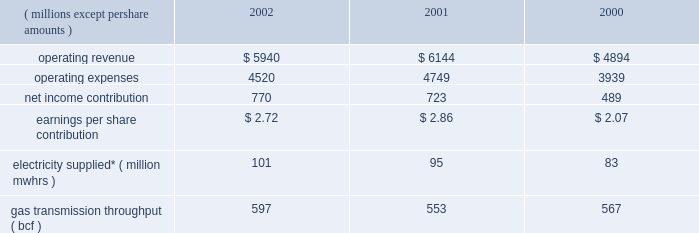Other taxes decreased in 2001 because its utility operations in virginia became subject to state income taxes in lieu of gross receipts taxes effective january 2001 .
In addition , dominion recognized higher effective rates for foreign earnings and higher pretax income in relation to non-conventional fuel tax credits realized .
Dominion energy 2002 2001 2000 ( millions , except per share amounts ) .
* amounts presented are for electricity supplied by utility and merchant generation operations .
Operating results 2014 2002 dominion energy contributed $ 2.72 per diluted share on net income of $ 770 million for 2002 , a net income increase of $ 47 million and an earnings per share decrease of $ 0.14 over 2001 .
Net income for 2002 reflected lower operating revenue ( $ 204 million ) , operating expenses ( $ 229 million ) and other income ( $ 27 million ) .
Interest expense and income taxes , which are discussed on a consolidated basis , decreased $ 50 million over 2001 .
The earnings per share decrease reflected share dilution .
Regulated electric sales revenue increased $ 179 million .
Favorable weather conditions , reflecting increased cooling and heating degree-days , as well as customer growth , are estimated to have contributed $ 133 million and $ 41 million , respectively .
Fuel rate recoveries increased approximately $ 65 million for 2002 .
These recoveries are generally offset by increases in elec- tric fuel expense and do not materially affect income .
Partially offsetting these increases was a net decrease of $ 60 million due to other factors not separately measurable , such as the impact of economic conditions on customer usage , as well as variations in seasonal rate premiums and discounts .
Nonregulated electric sales revenue increased $ 9 million .
Sales revenue from dominion 2019s merchant generation fleet decreased $ 21 million , reflecting a $ 201 million decline due to lower prices partially offset by sales from assets acquired and constructed in 2002 and the inclusion of millstone operations for all of 2002 .
Revenue from the wholesale marketing of utility generation decreased $ 74 million .
Due to the higher demand of utility service territory customers during 2002 , less production from utility plant generation was available for profitable sale in the wholesale market .
Revenue from retail energy sales increased $ 71 million , reflecting primarily customer growth over the prior year .
Net revenue from dominion 2019s electric trading activities increased $ 33 million , reflecting the effect of favorable price changes on unsettled contracts and higher trading margins .
Nonregulated gas sales revenue decreased $ 351 million .
The decrease included a $ 239 million decrease in sales by dominion 2019s field services and retail energy marketing opera- tions , reflecting to a large extent declining prices .
Revenue associated with gas trading operations , net of related cost of sales , decreased $ 112 million .
The decrease included $ 70 mil- lion of realized and unrealized losses on the economic hedges of natural gas production by the dominion exploration & pro- duction segment .
As described below under selected information 2014 energy trading activities , sales of natural gas by the dominion exploration & production segment at market prices offset these financial losses , resulting in a range of prices contemplated by dominion 2019s overall risk management strategy .
The remaining $ 42 million decrease was due to unfavorable price changes on unsettled contracts and lower overall trading margins .
Those losses were partially offset by contributions from higher trading volumes in gas and oil markets .
Gas transportation and storage revenue decreased $ 44 million , primarily reflecting lower rates .
Electric fuel and energy purchases expense increased $ 94 million which included an increase of $ 66 million associated with dominion 2019s energy marketing operations that are not sub- ject to cost-based rate regulation and an increase of $ 28 million associated with utility operations .
Substantially all of the increase associated with non-regulated energy marketing opera- tions related to higher volumes purchased during the year .
For utility operations , energy costs increased $ 66 million for pur- chases subject to rate recovery , partially offset by a $ 38 million decrease in fuel expenses associated with lower wholesale mar- keting of utility plant generation .
Purchased gas expense decreased $ 245 million associated with dominion 2019s field services and retail energy marketing oper- ations .
This decrease reflected approximately $ 162 million asso- ciated with declining prices and $ 83 million associated with lower purchased volumes .
Liquids , pipeline capacity and other purchases decreased $ 64 million , primarily reflecting comparably lower levels of rate recoveries of certain costs of transmission operations in the cur- rent year period .
The difference between actual expenses and amounts recovered in the period are deferred pending future rate adjustments .
Other operations and maintenance expense decreased $ 14 million , primarily reflecting an $ 18 million decrease in outage costs due to fewer generation unit outages in the current year .
Depreciation expense decreased $ 11 million , reflecting decreases in depreciation associated with changes in the esti- mated useful lives of certain electric generation property , par- tially offset by increased depreciation associated with state line and millstone operations .
Other income decreased $ 27 million , including a $ 14 mil- lion decrease in net realized investment gains in the millstone 37d o m i n i o n 2019 0 2 a n n u a l r e p o r t .
If the 2003 growth rate is the same as 2002 , what would 2003 electricity supplied equal ( million mwhrs ) ? 
Computations: (101 * (101 / 95))
Answer: 107.37895. 